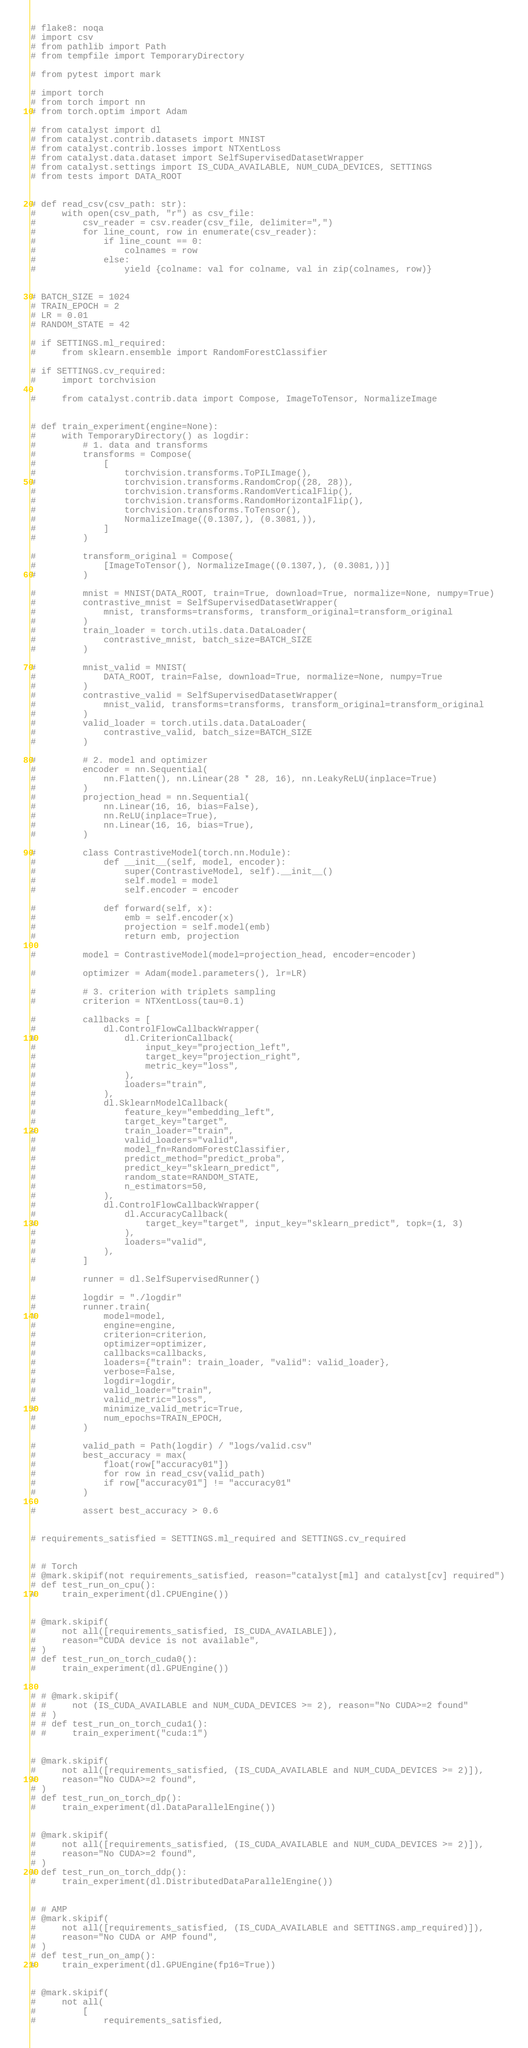<code> <loc_0><loc_0><loc_500><loc_500><_Python_># flake8: noqa
# import csv
# from pathlib import Path
# from tempfile import TemporaryDirectory

# from pytest import mark

# import torch
# from torch import nn
# from torch.optim import Adam

# from catalyst import dl
# from catalyst.contrib.datasets import MNIST
# from catalyst.contrib.losses import NTXentLoss
# from catalyst.data.dataset import SelfSupervisedDatasetWrapper
# from catalyst.settings import IS_CUDA_AVAILABLE, NUM_CUDA_DEVICES, SETTINGS
# from tests import DATA_ROOT


# def read_csv(csv_path: str):
#     with open(csv_path, "r") as csv_file:
#         csv_reader = csv.reader(csv_file, delimiter=",")
#         for line_count, row in enumerate(csv_reader):
#             if line_count == 0:
#                 colnames = row
#             else:
#                 yield {colname: val for colname, val in zip(colnames, row)}


# BATCH_SIZE = 1024
# TRAIN_EPOCH = 2
# LR = 0.01
# RANDOM_STATE = 42

# if SETTINGS.ml_required:
#     from sklearn.ensemble import RandomForestClassifier

# if SETTINGS.cv_required:
#     import torchvision

#     from catalyst.contrib.data import Compose, ImageToTensor, NormalizeImage


# def train_experiment(engine=None):
#     with TemporaryDirectory() as logdir:
#         # 1. data and transforms
#         transforms = Compose(
#             [
#                 torchvision.transforms.ToPILImage(),
#                 torchvision.transforms.RandomCrop((28, 28)),
#                 torchvision.transforms.RandomVerticalFlip(),
#                 torchvision.transforms.RandomHorizontalFlip(),
#                 torchvision.transforms.ToTensor(),
#                 NormalizeImage((0.1307,), (0.3081,)),
#             ]
#         )

#         transform_original = Compose(
#             [ImageToTensor(), NormalizeImage((0.1307,), (0.3081,))]
#         )

#         mnist = MNIST(DATA_ROOT, train=True, download=True, normalize=None, numpy=True)
#         contrastive_mnist = SelfSupervisedDatasetWrapper(
#             mnist, transforms=transforms, transform_original=transform_original
#         )
#         train_loader = torch.utils.data.DataLoader(
#             contrastive_mnist, batch_size=BATCH_SIZE
#         )

#         mnist_valid = MNIST(
#             DATA_ROOT, train=False, download=True, normalize=None, numpy=True
#         )
#         contrastive_valid = SelfSupervisedDatasetWrapper(
#             mnist_valid, transforms=transforms, transform_original=transform_original
#         )
#         valid_loader = torch.utils.data.DataLoader(
#             contrastive_valid, batch_size=BATCH_SIZE
#         )

#         # 2. model and optimizer
#         encoder = nn.Sequential(
#             nn.Flatten(), nn.Linear(28 * 28, 16), nn.LeakyReLU(inplace=True)
#         )
#         projection_head = nn.Sequential(
#             nn.Linear(16, 16, bias=False),
#             nn.ReLU(inplace=True),
#             nn.Linear(16, 16, bias=True),
#         )

#         class ContrastiveModel(torch.nn.Module):
#             def __init__(self, model, encoder):
#                 super(ContrastiveModel, self).__init__()
#                 self.model = model
#                 self.encoder = encoder

#             def forward(self, x):
#                 emb = self.encoder(x)
#                 projection = self.model(emb)
#                 return emb, projection

#         model = ContrastiveModel(model=projection_head, encoder=encoder)

#         optimizer = Adam(model.parameters(), lr=LR)

#         # 3. criterion with triplets sampling
#         criterion = NTXentLoss(tau=0.1)

#         callbacks = [
#             dl.ControlFlowCallbackWrapper(
#                 dl.CriterionCallback(
#                     input_key="projection_left",
#                     target_key="projection_right",
#                     metric_key="loss",
#                 ),
#                 loaders="train",
#             ),
#             dl.SklearnModelCallback(
#                 feature_key="embedding_left",
#                 target_key="target",
#                 train_loader="train",
#                 valid_loaders="valid",
#                 model_fn=RandomForestClassifier,
#                 predict_method="predict_proba",
#                 predict_key="sklearn_predict",
#                 random_state=RANDOM_STATE,
#                 n_estimators=50,
#             ),
#             dl.ControlFlowCallbackWrapper(
#                 dl.AccuracyCallback(
#                     target_key="target", input_key="sklearn_predict", topk=(1, 3)
#                 ),
#                 loaders="valid",
#             ),
#         ]

#         runner = dl.SelfSupervisedRunner()

#         logdir = "./logdir"
#         runner.train(
#             model=model,
#             engine=engine,
#             criterion=criterion,
#             optimizer=optimizer,
#             callbacks=callbacks,
#             loaders={"train": train_loader, "valid": valid_loader},
#             verbose=False,
#             logdir=logdir,
#             valid_loader="train",
#             valid_metric="loss",
#             minimize_valid_metric=True,
#             num_epochs=TRAIN_EPOCH,
#         )

#         valid_path = Path(logdir) / "logs/valid.csv"
#         best_accuracy = max(
#             float(row["accuracy01"])
#             for row in read_csv(valid_path)
#             if row["accuracy01"] != "accuracy01"
#         )

#         assert best_accuracy > 0.6


# requirements_satisfied = SETTINGS.ml_required and SETTINGS.cv_required


# # Torch
# @mark.skipif(not requirements_satisfied, reason="catalyst[ml] and catalyst[cv] required")
# def test_run_on_cpu():
#     train_experiment(dl.CPUEngine())


# @mark.skipif(
#     not all([requirements_satisfied, IS_CUDA_AVAILABLE]),
#     reason="CUDA device is not available",
# )
# def test_run_on_torch_cuda0():
#     train_experiment(dl.GPUEngine())


# # @mark.skipif(
# #     not (IS_CUDA_AVAILABLE and NUM_CUDA_DEVICES >= 2), reason="No CUDA>=2 found"
# # )
# # def test_run_on_torch_cuda1():
# #     train_experiment("cuda:1")


# @mark.skipif(
#     not all([requirements_satisfied, (IS_CUDA_AVAILABLE and NUM_CUDA_DEVICES >= 2)]),
#     reason="No CUDA>=2 found",
# )
# def test_run_on_torch_dp():
#     train_experiment(dl.DataParallelEngine())


# @mark.skipif(
#     not all([requirements_satisfied, (IS_CUDA_AVAILABLE and NUM_CUDA_DEVICES >= 2)]),
#     reason="No CUDA>=2 found",
# )
# def test_run_on_torch_ddp():
#     train_experiment(dl.DistributedDataParallelEngine())


# # AMP
# @mark.skipif(
#     not all([requirements_satisfied, (IS_CUDA_AVAILABLE and SETTINGS.amp_required)]),
#     reason="No CUDA or AMP found",
# )
# def test_run_on_amp():
#     train_experiment(dl.GPUEngine(fp16=True))


# @mark.skipif(
#     not all(
#         [
#             requirements_satisfied,</code> 